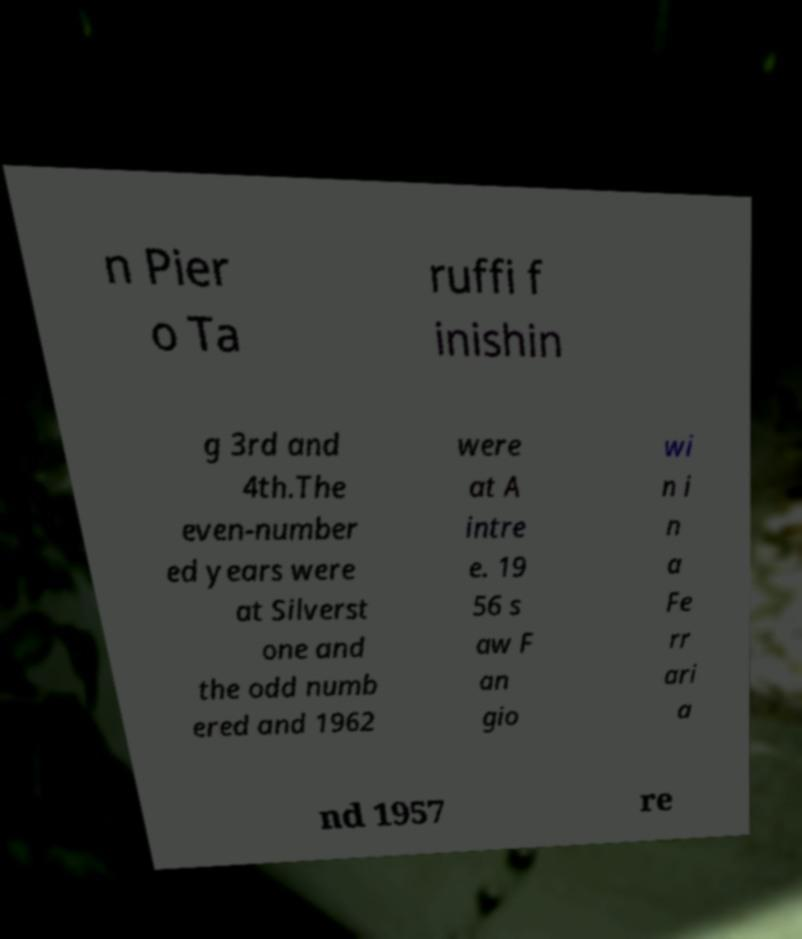I need the written content from this picture converted into text. Can you do that? n Pier o Ta ruffi f inishin g 3rd and 4th.The even-number ed years were at Silverst one and the odd numb ered and 1962 were at A intre e. 19 56 s aw F an gio wi n i n a Fe rr ari a nd 1957 re 